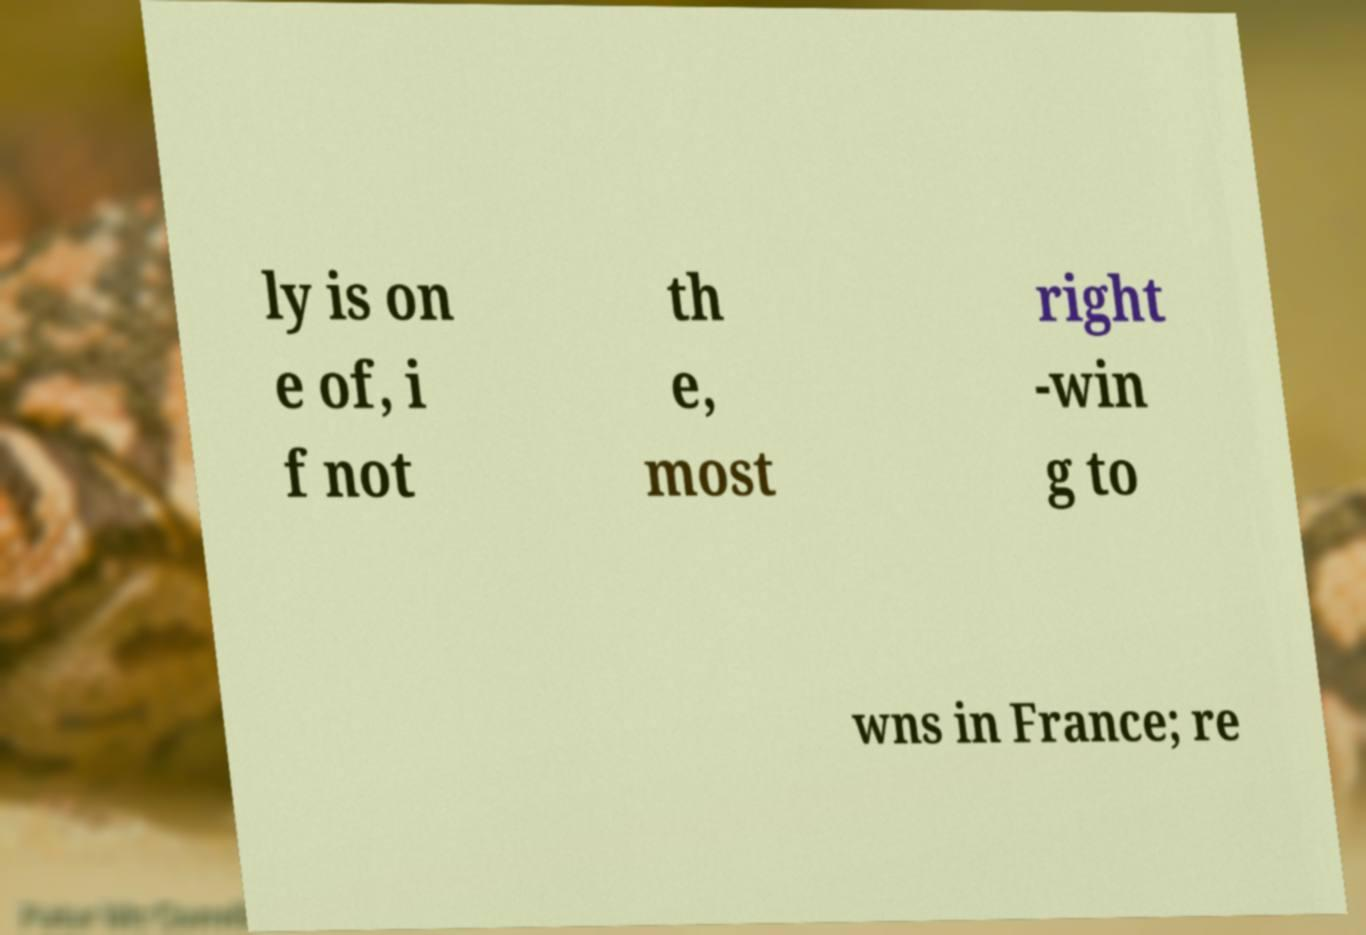Please identify and transcribe the text found in this image. ly is on e of, i f not th e, most right -win g to wns in France; re 